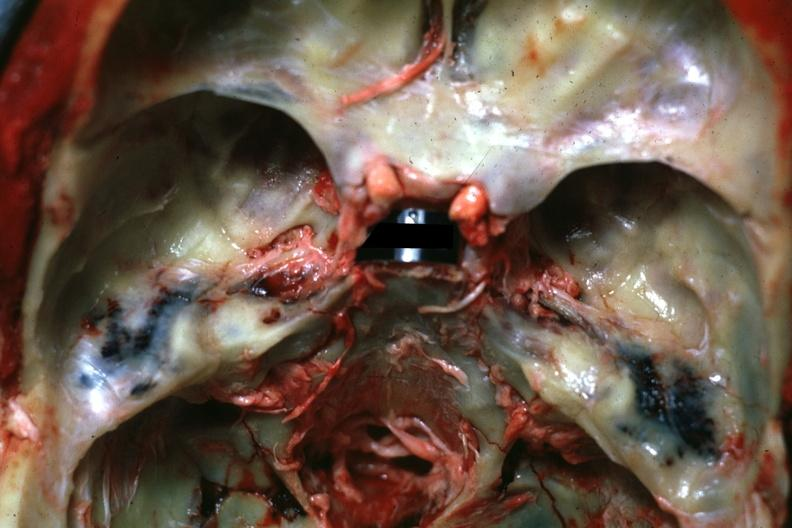what does this image show?
Answer the question using a single word or phrase. View of middle ear areas with obvious hemorrhage in under-lying tissue 